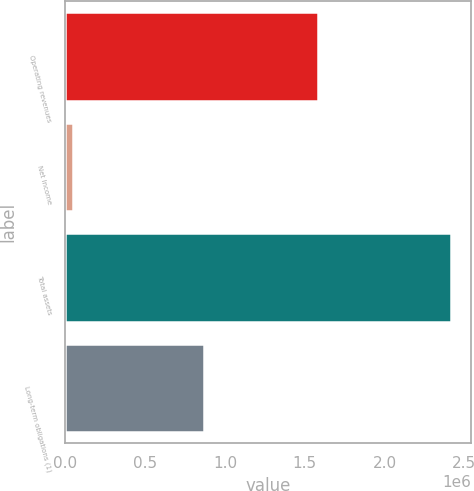<chart> <loc_0><loc_0><loc_500><loc_500><bar_chart><fcel>Operating revenues<fcel>Net Income<fcel>Total assets<fcel>Long-term obligations (1)<nl><fcel>1.58214e+06<fcel>51136<fcel>2.41979e+06<fcel>870975<nl></chart> 